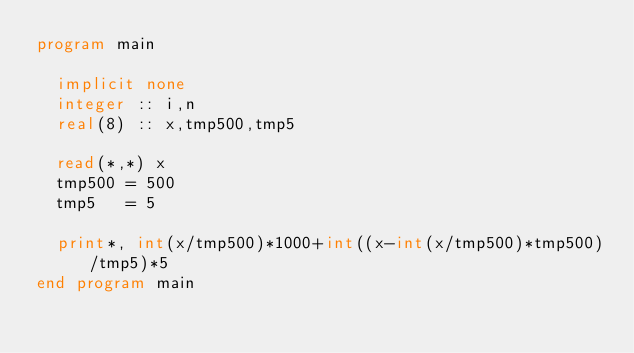<code> <loc_0><loc_0><loc_500><loc_500><_FORTRAN_>program main
  
  implicit none
  integer :: i,n
  real(8) :: x,tmp500,tmp5
  
  read(*,*) x
  tmp500 = 500
  tmp5   = 5
  
  print*, int(x/tmp500)*1000+int((x-int(x/tmp500)*tmp500)/tmp5)*5  
end program main
</code> 